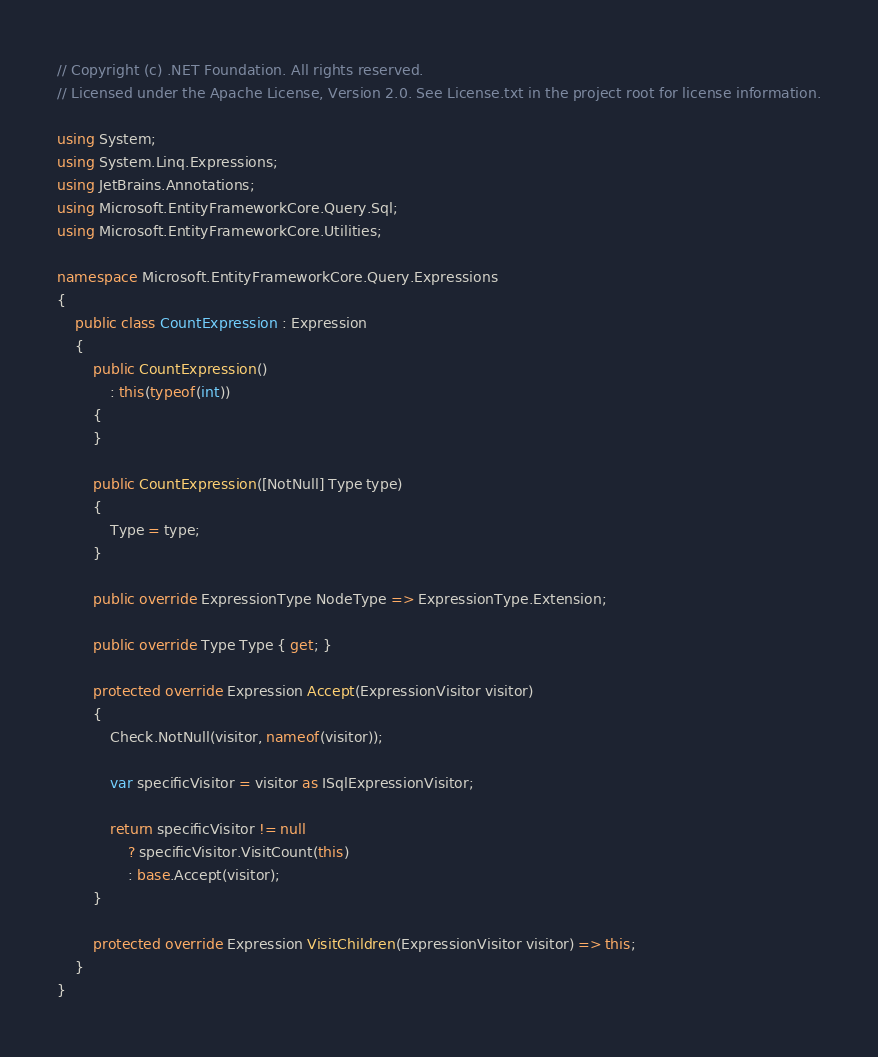Convert code to text. <code><loc_0><loc_0><loc_500><loc_500><_C#_>// Copyright (c) .NET Foundation. All rights reserved.
// Licensed under the Apache License, Version 2.0. See License.txt in the project root for license information.

using System;
using System.Linq.Expressions;
using JetBrains.Annotations;
using Microsoft.EntityFrameworkCore.Query.Sql;
using Microsoft.EntityFrameworkCore.Utilities;

namespace Microsoft.EntityFrameworkCore.Query.Expressions
{
    public class CountExpression : Expression
    {
        public CountExpression()
            : this(typeof(int))
        {
        }

        public CountExpression([NotNull] Type type)
        {
            Type = type;
        }

        public override ExpressionType NodeType => ExpressionType.Extension;

        public override Type Type { get; }

        protected override Expression Accept(ExpressionVisitor visitor)
        {
            Check.NotNull(visitor, nameof(visitor));

            var specificVisitor = visitor as ISqlExpressionVisitor;

            return specificVisitor != null
                ? specificVisitor.VisitCount(this)
                : base.Accept(visitor);
        }

        protected override Expression VisitChildren(ExpressionVisitor visitor) => this;
    }
}
</code> 